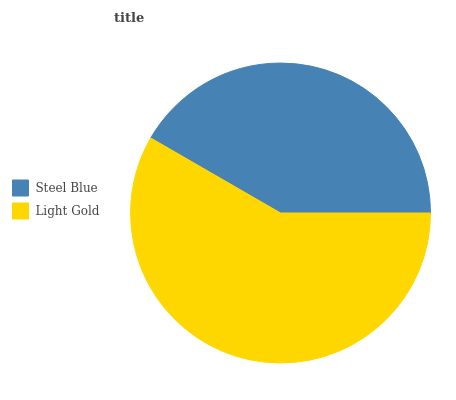Is Steel Blue the minimum?
Answer yes or no. Yes. Is Light Gold the maximum?
Answer yes or no. Yes. Is Light Gold the minimum?
Answer yes or no. No. Is Light Gold greater than Steel Blue?
Answer yes or no. Yes. Is Steel Blue less than Light Gold?
Answer yes or no. Yes. Is Steel Blue greater than Light Gold?
Answer yes or no. No. Is Light Gold less than Steel Blue?
Answer yes or no. No. Is Light Gold the high median?
Answer yes or no. Yes. Is Steel Blue the low median?
Answer yes or no. Yes. Is Steel Blue the high median?
Answer yes or no. No. Is Light Gold the low median?
Answer yes or no. No. 